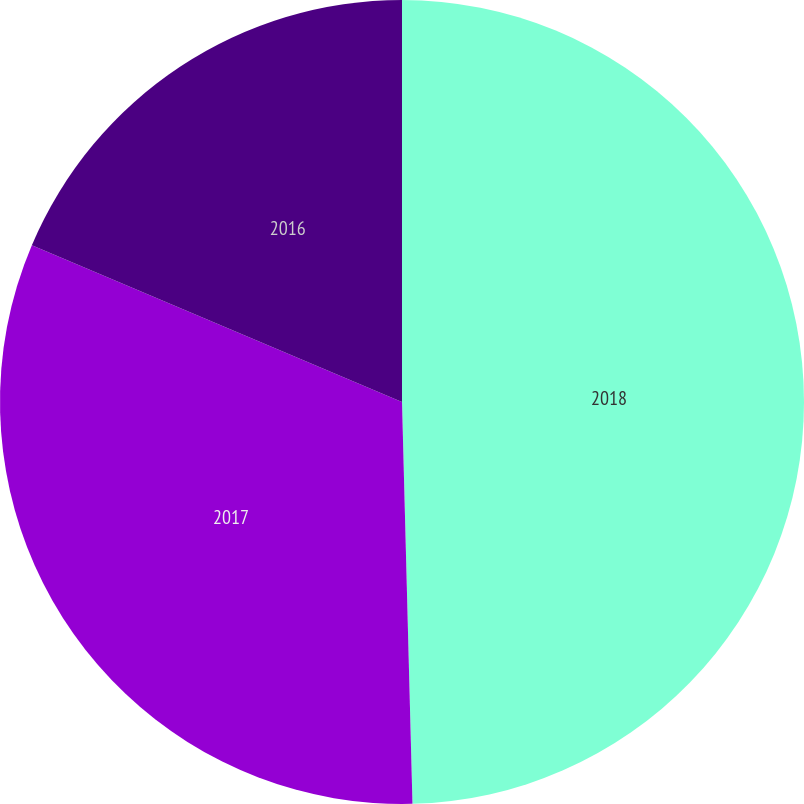Convert chart. <chart><loc_0><loc_0><loc_500><loc_500><pie_chart><fcel>2018<fcel>2017<fcel>2016<nl><fcel>49.58%<fcel>31.79%<fcel>18.62%<nl></chart> 